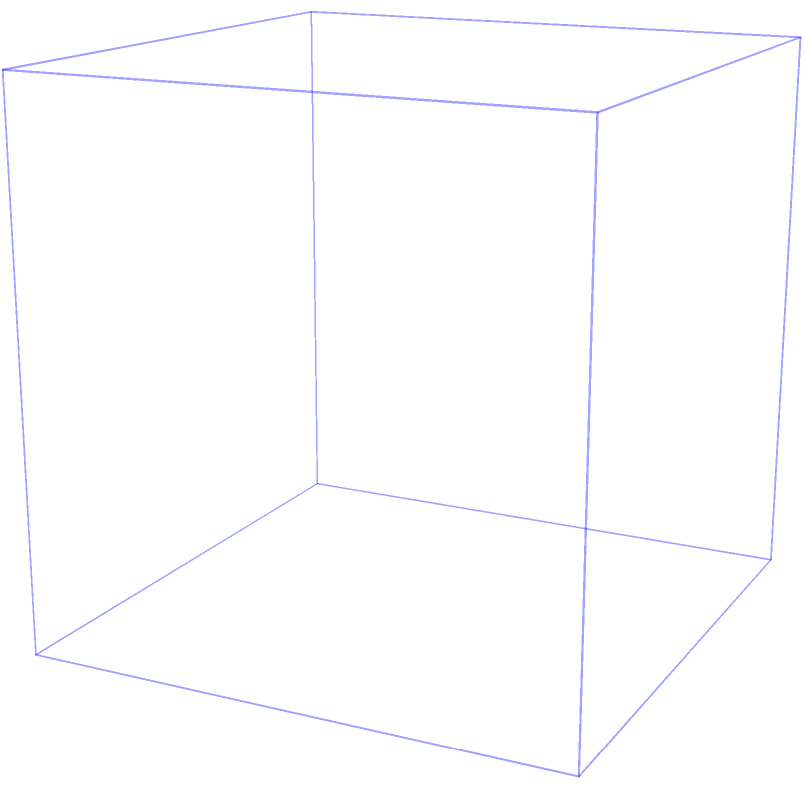In the realm of classical sculpture, a master artisan has crafted a perfect marble sphere within a cubic block. If the sphere touches each face of the cube without protruding, what is the ratio of the volume of the sphere to the volume of the cube? How does this mathematical relationship reflect the aesthetic balance between form and negative space in traditional sculptural techniques? To solve this problem, let's approach it step-by-step, considering both the mathematical and artistic aspects:

1) First, let's define our variables:
   Let $r$ be the radius of the sphere
   Let $a$ be the side length of the cube

2) Since the sphere touches each face of the cube, we know that the diameter of the sphere equals the side length of the cube:
   $2r = a$

3) The volume of a cube is given by $V_{cube} = a^3$

4) The volume of a sphere is given by $V_{sphere} = \frac{4}{3}\pi r^3$

5) We can express the radius in terms of the cube's side length:
   $r = \frac{a}{2}$

6) Now, let's calculate the ratio of the volumes:

   $$\frac{V_{sphere}}{V_{cube}} = \frac{\frac{4}{3}\pi r^3}{a^3} = \frac{\frac{4}{3}\pi (\frac{a}{2})^3}{a^3} = \frac{\frac{4}{3}\pi \frac{a^3}{8}}{a^3} = \frac{\pi}{6} \approx 0.5236$$

7) This ratio, $\frac{\pi}{6}$, is a fundamental relationship in classical geometry, reflecting the harmony between curved and linear forms.

From an artistic perspective, this ratio represents the delicate balance between the sculpted form (the sphere) and the negative space surrounding it within the cube. The fact that the sphere occupies approximately 52.36% of the cube's volume leaves ample space for the viewer's imagination, a principle often employed in traditional sculptural techniques. This mathematical relationship underscores the precision and thoughtfulness involved in classical sculpting, where every proportion is carefully considered to achieve aesthetic harmony.
Answer: $\frac{\pi}{6}$ 